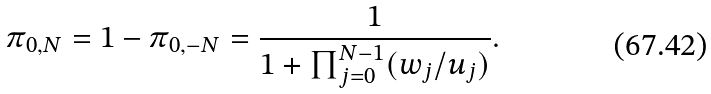<formula> <loc_0><loc_0><loc_500><loc_500>\pi _ { 0 , N } = 1 - \pi _ { 0 , - N } = \frac { 1 } { 1 + \prod _ { j = 0 } ^ { N - 1 } ( w _ { j } / u _ { j } ) } .</formula> 